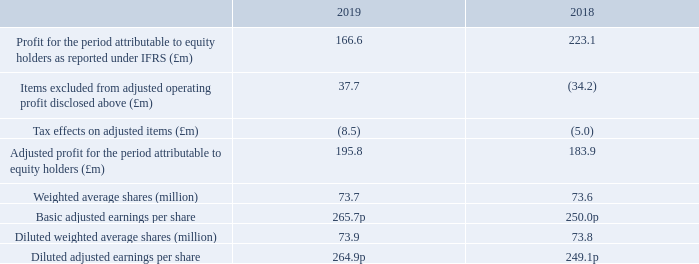Adjusted earnings per share
Basic adjusted earnings per share is defined as adjusted profit for the period attributable to equity holders divided by the weighted average number of shares. Diluted adjusted earnings per share is defined as adjusted profit for the period attributable to equity holders divided by the diluted weighted average number of shares.
Basic and diluted EPS calculated on an IFRS profit basis are included in Note 10.
How is basic adjusted earnings per share defined as? Adjusted profit for the period attributable to equity holders divided by the weighted average number of shares. How is diluted adjusted earnings per share defined as? Adjusted profit for the period attributable to equity holders divided by the diluted weighted average number of shares. What is the Tax effects on adjusted items for 2018 and 2019 respectively?
Answer scale should be: million. (5.0), (8.5). In which year was the basic adjusted earnings per share larger? 265.7p>250.0p
Answer: 2019. What was the change in the profit for the period attributable to equity holders as reported under IFRS in 2019 from 2018?
Answer scale should be: million. 166.6-223.1
Answer: -56.5. What was the percentage change in the profit for the period attributable to equity holders as reported under IFRS in 2019 from 2018?
Answer scale should be: percent. (166.6-223.1)/223.1
Answer: -25.32. 